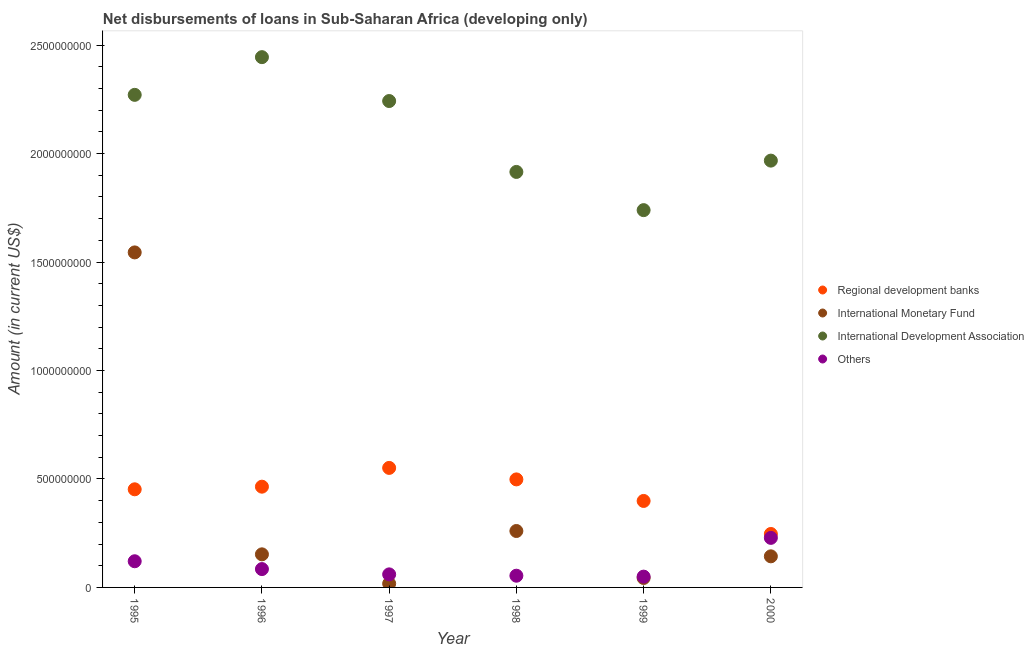How many different coloured dotlines are there?
Offer a terse response. 4. What is the amount of loan disimbursed by international development association in 1997?
Make the answer very short. 2.24e+09. Across all years, what is the maximum amount of loan disimbursed by other organisations?
Offer a very short reply. 2.28e+08. Across all years, what is the minimum amount of loan disimbursed by international monetary fund?
Your response must be concise. 1.76e+07. In which year was the amount of loan disimbursed by other organisations maximum?
Your answer should be compact. 2000. In which year was the amount of loan disimbursed by international monetary fund minimum?
Provide a short and direct response. 1997. What is the total amount of loan disimbursed by other organisations in the graph?
Give a very brief answer. 5.98e+08. What is the difference between the amount of loan disimbursed by international monetary fund in 1997 and that in 1998?
Ensure brevity in your answer.  -2.43e+08. What is the difference between the amount of loan disimbursed by other organisations in 1998 and the amount of loan disimbursed by international monetary fund in 1996?
Provide a succinct answer. -9.85e+07. What is the average amount of loan disimbursed by international monetary fund per year?
Make the answer very short. 3.60e+08. In the year 1996, what is the difference between the amount of loan disimbursed by international monetary fund and amount of loan disimbursed by other organisations?
Offer a very short reply. 6.80e+07. In how many years, is the amount of loan disimbursed by international development association greater than 900000000 US$?
Provide a succinct answer. 6. What is the ratio of the amount of loan disimbursed by other organisations in 1996 to that in 1997?
Provide a short and direct response. 1.41. Is the amount of loan disimbursed by international development association in 1997 less than that in 1999?
Your answer should be compact. No. Is the difference between the amount of loan disimbursed by international development association in 1995 and 1997 greater than the difference between the amount of loan disimbursed by regional development banks in 1995 and 1997?
Offer a very short reply. Yes. What is the difference between the highest and the second highest amount of loan disimbursed by other organisations?
Offer a very short reply. 1.08e+08. What is the difference between the highest and the lowest amount of loan disimbursed by regional development banks?
Provide a short and direct response. 3.05e+08. In how many years, is the amount of loan disimbursed by international monetary fund greater than the average amount of loan disimbursed by international monetary fund taken over all years?
Make the answer very short. 1. Is it the case that in every year, the sum of the amount of loan disimbursed by regional development banks and amount of loan disimbursed by international monetary fund is greater than the sum of amount of loan disimbursed by international development association and amount of loan disimbursed by other organisations?
Offer a very short reply. No. Is it the case that in every year, the sum of the amount of loan disimbursed by regional development banks and amount of loan disimbursed by international monetary fund is greater than the amount of loan disimbursed by international development association?
Ensure brevity in your answer.  No. Is the amount of loan disimbursed by regional development banks strictly greater than the amount of loan disimbursed by other organisations over the years?
Your response must be concise. Yes. How many dotlines are there?
Your answer should be very brief. 4. What is the difference between two consecutive major ticks on the Y-axis?
Offer a very short reply. 5.00e+08. Are the values on the major ticks of Y-axis written in scientific E-notation?
Your answer should be compact. No. How many legend labels are there?
Your answer should be compact. 4. What is the title of the graph?
Your answer should be compact. Net disbursements of loans in Sub-Saharan Africa (developing only). Does "Austria" appear as one of the legend labels in the graph?
Offer a very short reply. No. What is the label or title of the X-axis?
Offer a terse response. Year. What is the label or title of the Y-axis?
Your response must be concise. Amount (in current US$). What is the Amount (in current US$) in Regional development banks in 1995?
Keep it short and to the point. 4.52e+08. What is the Amount (in current US$) of International Monetary Fund in 1995?
Your response must be concise. 1.54e+09. What is the Amount (in current US$) in International Development Association in 1995?
Make the answer very short. 2.27e+09. What is the Amount (in current US$) of Others in 1995?
Offer a very short reply. 1.21e+08. What is the Amount (in current US$) of Regional development banks in 1996?
Provide a short and direct response. 4.64e+08. What is the Amount (in current US$) in International Monetary Fund in 1996?
Your answer should be compact. 1.53e+08. What is the Amount (in current US$) of International Development Association in 1996?
Offer a terse response. 2.44e+09. What is the Amount (in current US$) of Others in 1996?
Keep it short and to the point. 8.46e+07. What is the Amount (in current US$) in Regional development banks in 1997?
Give a very brief answer. 5.51e+08. What is the Amount (in current US$) in International Monetary Fund in 1997?
Give a very brief answer. 1.76e+07. What is the Amount (in current US$) in International Development Association in 1997?
Offer a very short reply. 2.24e+09. What is the Amount (in current US$) in Others in 1997?
Your response must be concise. 6.02e+07. What is the Amount (in current US$) in Regional development banks in 1998?
Provide a short and direct response. 4.98e+08. What is the Amount (in current US$) of International Monetary Fund in 1998?
Your answer should be very brief. 2.60e+08. What is the Amount (in current US$) of International Development Association in 1998?
Your answer should be very brief. 1.92e+09. What is the Amount (in current US$) in Others in 1998?
Make the answer very short. 5.40e+07. What is the Amount (in current US$) of Regional development banks in 1999?
Your answer should be compact. 3.99e+08. What is the Amount (in current US$) in International Monetary Fund in 1999?
Ensure brevity in your answer.  4.36e+07. What is the Amount (in current US$) of International Development Association in 1999?
Ensure brevity in your answer.  1.74e+09. What is the Amount (in current US$) of Others in 1999?
Your answer should be compact. 4.98e+07. What is the Amount (in current US$) in Regional development banks in 2000?
Your answer should be very brief. 2.46e+08. What is the Amount (in current US$) in International Monetary Fund in 2000?
Make the answer very short. 1.43e+08. What is the Amount (in current US$) in International Development Association in 2000?
Ensure brevity in your answer.  1.97e+09. What is the Amount (in current US$) in Others in 2000?
Give a very brief answer. 2.28e+08. Across all years, what is the maximum Amount (in current US$) in Regional development banks?
Make the answer very short. 5.51e+08. Across all years, what is the maximum Amount (in current US$) of International Monetary Fund?
Your answer should be compact. 1.54e+09. Across all years, what is the maximum Amount (in current US$) of International Development Association?
Your answer should be compact. 2.44e+09. Across all years, what is the maximum Amount (in current US$) of Others?
Keep it short and to the point. 2.28e+08. Across all years, what is the minimum Amount (in current US$) in Regional development banks?
Offer a terse response. 2.46e+08. Across all years, what is the minimum Amount (in current US$) of International Monetary Fund?
Make the answer very short. 1.76e+07. Across all years, what is the minimum Amount (in current US$) of International Development Association?
Ensure brevity in your answer.  1.74e+09. Across all years, what is the minimum Amount (in current US$) in Others?
Your response must be concise. 4.98e+07. What is the total Amount (in current US$) in Regional development banks in the graph?
Your response must be concise. 2.61e+09. What is the total Amount (in current US$) of International Monetary Fund in the graph?
Offer a very short reply. 2.16e+09. What is the total Amount (in current US$) of International Development Association in the graph?
Your answer should be very brief. 1.26e+1. What is the total Amount (in current US$) in Others in the graph?
Offer a terse response. 5.98e+08. What is the difference between the Amount (in current US$) of Regional development banks in 1995 and that in 1996?
Your answer should be compact. -1.21e+07. What is the difference between the Amount (in current US$) of International Monetary Fund in 1995 and that in 1996?
Give a very brief answer. 1.39e+09. What is the difference between the Amount (in current US$) of International Development Association in 1995 and that in 1996?
Offer a terse response. -1.74e+08. What is the difference between the Amount (in current US$) in Others in 1995 and that in 1996?
Your answer should be compact. 3.61e+07. What is the difference between the Amount (in current US$) of Regional development banks in 1995 and that in 1997?
Your answer should be very brief. -9.86e+07. What is the difference between the Amount (in current US$) in International Monetary Fund in 1995 and that in 1997?
Ensure brevity in your answer.  1.53e+09. What is the difference between the Amount (in current US$) in International Development Association in 1995 and that in 1997?
Make the answer very short. 2.85e+07. What is the difference between the Amount (in current US$) in Others in 1995 and that in 1997?
Make the answer very short. 6.05e+07. What is the difference between the Amount (in current US$) of Regional development banks in 1995 and that in 1998?
Offer a terse response. -4.57e+07. What is the difference between the Amount (in current US$) of International Monetary Fund in 1995 and that in 1998?
Provide a short and direct response. 1.28e+09. What is the difference between the Amount (in current US$) in International Development Association in 1995 and that in 1998?
Your response must be concise. 3.55e+08. What is the difference between the Amount (in current US$) in Others in 1995 and that in 1998?
Provide a succinct answer. 6.67e+07. What is the difference between the Amount (in current US$) in Regional development banks in 1995 and that in 1999?
Make the answer very short. 5.37e+07. What is the difference between the Amount (in current US$) of International Monetary Fund in 1995 and that in 1999?
Make the answer very short. 1.50e+09. What is the difference between the Amount (in current US$) in International Development Association in 1995 and that in 1999?
Provide a succinct answer. 5.31e+08. What is the difference between the Amount (in current US$) of Others in 1995 and that in 1999?
Keep it short and to the point. 7.09e+07. What is the difference between the Amount (in current US$) in Regional development banks in 1995 and that in 2000?
Your response must be concise. 2.06e+08. What is the difference between the Amount (in current US$) of International Monetary Fund in 1995 and that in 2000?
Your response must be concise. 1.40e+09. What is the difference between the Amount (in current US$) of International Development Association in 1995 and that in 2000?
Your response must be concise. 3.03e+08. What is the difference between the Amount (in current US$) in Others in 1995 and that in 2000?
Your answer should be compact. -1.08e+08. What is the difference between the Amount (in current US$) of Regional development banks in 1996 and that in 1997?
Offer a terse response. -8.65e+07. What is the difference between the Amount (in current US$) in International Monetary Fund in 1996 and that in 1997?
Give a very brief answer. 1.35e+08. What is the difference between the Amount (in current US$) in International Development Association in 1996 and that in 1997?
Provide a succinct answer. 2.02e+08. What is the difference between the Amount (in current US$) of Others in 1996 and that in 1997?
Offer a very short reply. 2.44e+07. What is the difference between the Amount (in current US$) in Regional development banks in 1996 and that in 1998?
Ensure brevity in your answer.  -3.36e+07. What is the difference between the Amount (in current US$) of International Monetary Fund in 1996 and that in 1998?
Provide a succinct answer. -1.08e+08. What is the difference between the Amount (in current US$) in International Development Association in 1996 and that in 1998?
Your response must be concise. 5.29e+08. What is the difference between the Amount (in current US$) in Others in 1996 and that in 1998?
Offer a terse response. 3.06e+07. What is the difference between the Amount (in current US$) in Regional development banks in 1996 and that in 1999?
Give a very brief answer. 6.58e+07. What is the difference between the Amount (in current US$) of International Monetary Fund in 1996 and that in 1999?
Give a very brief answer. 1.09e+08. What is the difference between the Amount (in current US$) in International Development Association in 1996 and that in 1999?
Your response must be concise. 7.05e+08. What is the difference between the Amount (in current US$) of Others in 1996 and that in 1999?
Provide a short and direct response. 3.48e+07. What is the difference between the Amount (in current US$) in Regional development banks in 1996 and that in 2000?
Offer a terse response. 2.18e+08. What is the difference between the Amount (in current US$) in International Monetary Fund in 1996 and that in 2000?
Ensure brevity in your answer.  9.20e+06. What is the difference between the Amount (in current US$) of International Development Association in 1996 and that in 2000?
Offer a very short reply. 4.77e+08. What is the difference between the Amount (in current US$) in Others in 1996 and that in 2000?
Offer a very short reply. -1.44e+08. What is the difference between the Amount (in current US$) in Regional development banks in 1997 and that in 1998?
Provide a succinct answer. 5.30e+07. What is the difference between the Amount (in current US$) of International Monetary Fund in 1997 and that in 1998?
Make the answer very short. -2.43e+08. What is the difference between the Amount (in current US$) of International Development Association in 1997 and that in 1998?
Give a very brief answer. 3.27e+08. What is the difference between the Amount (in current US$) of Others in 1997 and that in 1998?
Your response must be concise. 6.17e+06. What is the difference between the Amount (in current US$) of Regional development banks in 1997 and that in 1999?
Your answer should be very brief. 1.52e+08. What is the difference between the Amount (in current US$) in International Monetary Fund in 1997 and that in 1999?
Ensure brevity in your answer.  -2.60e+07. What is the difference between the Amount (in current US$) of International Development Association in 1997 and that in 1999?
Your answer should be compact. 5.03e+08. What is the difference between the Amount (in current US$) of Others in 1997 and that in 1999?
Keep it short and to the point. 1.04e+07. What is the difference between the Amount (in current US$) in Regional development banks in 1997 and that in 2000?
Make the answer very short. 3.05e+08. What is the difference between the Amount (in current US$) in International Monetary Fund in 1997 and that in 2000?
Provide a short and direct response. -1.26e+08. What is the difference between the Amount (in current US$) in International Development Association in 1997 and that in 2000?
Your response must be concise. 2.75e+08. What is the difference between the Amount (in current US$) of Others in 1997 and that in 2000?
Your answer should be very brief. -1.68e+08. What is the difference between the Amount (in current US$) in Regional development banks in 1998 and that in 1999?
Your answer should be compact. 9.93e+07. What is the difference between the Amount (in current US$) in International Monetary Fund in 1998 and that in 1999?
Provide a succinct answer. 2.17e+08. What is the difference between the Amount (in current US$) in International Development Association in 1998 and that in 1999?
Your answer should be very brief. 1.76e+08. What is the difference between the Amount (in current US$) of Others in 1998 and that in 1999?
Ensure brevity in your answer.  4.21e+06. What is the difference between the Amount (in current US$) of Regional development banks in 1998 and that in 2000?
Keep it short and to the point. 2.52e+08. What is the difference between the Amount (in current US$) of International Monetary Fund in 1998 and that in 2000?
Your answer should be compact. 1.17e+08. What is the difference between the Amount (in current US$) of International Development Association in 1998 and that in 2000?
Your answer should be compact. -5.22e+07. What is the difference between the Amount (in current US$) of Others in 1998 and that in 2000?
Make the answer very short. -1.74e+08. What is the difference between the Amount (in current US$) in Regional development banks in 1999 and that in 2000?
Keep it short and to the point. 1.52e+08. What is the difference between the Amount (in current US$) of International Monetary Fund in 1999 and that in 2000?
Provide a succinct answer. -9.98e+07. What is the difference between the Amount (in current US$) of International Development Association in 1999 and that in 2000?
Provide a succinct answer. -2.28e+08. What is the difference between the Amount (in current US$) in Others in 1999 and that in 2000?
Your response must be concise. -1.79e+08. What is the difference between the Amount (in current US$) in Regional development banks in 1995 and the Amount (in current US$) in International Monetary Fund in 1996?
Your answer should be very brief. 3.00e+08. What is the difference between the Amount (in current US$) in Regional development banks in 1995 and the Amount (in current US$) in International Development Association in 1996?
Your response must be concise. -1.99e+09. What is the difference between the Amount (in current US$) in Regional development banks in 1995 and the Amount (in current US$) in Others in 1996?
Your answer should be compact. 3.68e+08. What is the difference between the Amount (in current US$) in International Monetary Fund in 1995 and the Amount (in current US$) in International Development Association in 1996?
Make the answer very short. -9.00e+08. What is the difference between the Amount (in current US$) in International Monetary Fund in 1995 and the Amount (in current US$) in Others in 1996?
Your response must be concise. 1.46e+09. What is the difference between the Amount (in current US$) of International Development Association in 1995 and the Amount (in current US$) of Others in 1996?
Give a very brief answer. 2.19e+09. What is the difference between the Amount (in current US$) of Regional development banks in 1995 and the Amount (in current US$) of International Monetary Fund in 1997?
Offer a very short reply. 4.35e+08. What is the difference between the Amount (in current US$) of Regional development banks in 1995 and the Amount (in current US$) of International Development Association in 1997?
Make the answer very short. -1.79e+09. What is the difference between the Amount (in current US$) of Regional development banks in 1995 and the Amount (in current US$) of Others in 1997?
Offer a terse response. 3.92e+08. What is the difference between the Amount (in current US$) of International Monetary Fund in 1995 and the Amount (in current US$) of International Development Association in 1997?
Keep it short and to the point. -6.98e+08. What is the difference between the Amount (in current US$) in International Monetary Fund in 1995 and the Amount (in current US$) in Others in 1997?
Provide a succinct answer. 1.48e+09. What is the difference between the Amount (in current US$) of International Development Association in 1995 and the Amount (in current US$) of Others in 1997?
Offer a very short reply. 2.21e+09. What is the difference between the Amount (in current US$) of Regional development banks in 1995 and the Amount (in current US$) of International Monetary Fund in 1998?
Provide a succinct answer. 1.92e+08. What is the difference between the Amount (in current US$) in Regional development banks in 1995 and the Amount (in current US$) in International Development Association in 1998?
Keep it short and to the point. -1.46e+09. What is the difference between the Amount (in current US$) of Regional development banks in 1995 and the Amount (in current US$) of Others in 1998?
Make the answer very short. 3.98e+08. What is the difference between the Amount (in current US$) in International Monetary Fund in 1995 and the Amount (in current US$) in International Development Association in 1998?
Offer a very short reply. -3.71e+08. What is the difference between the Amount (in current US$) of International Monetary Fund in 1995 and the Amount (in current US$) of Others in 1998?
Offer a very short reply. 1.49e+09. What is the difference between the Amount (in current US$) in International Development Association in 1995 and the Amount (in current US$) in Others in 1998?
Your response must be concise. 2.22e+09. What is the difference between the Amount (in current US$) in Regional development banks in 1995 and the Amount (in current US$) in International Monetary Fund in 1999?
Offer a very short reply. 4.09e+08. What is the difference between the Amount (in current US$) in Regional development banks in 1995 and the Amount (in current US$) in International Development Association in 1999?
Your answer should be compact. -1.29e+09. What is the difference between the Amount (in current US$) in Regional development banks in 1995 and the Amount (in current US$) in Others in 1999?
Keep it short and to the point. 4.03e+08. What is the difference between the Amount (in current US$) of International Monetary Fund in 1995 and the Amount (in current US$) of International Development Association in 1999?
Make the answer very short. -1.95e+08. What is the difference between the Amount (in current US$) in International Monetary Fund in 1995 and the Amount (in current US$) in Others in 1999?
Keep it short and to the point. 1.49e+09. What is the difference between the Amount (in current US$) of International Development Association in 1995 and the Amount (in current US$) of Others in 1999?
Ensure brevity in your answer.  2.22e+09. What is the difference between the Amount (in current US$) in Regional development banks in 1995 and the Amount (in current US$) in International Monetary Fund in 2000?
Keep it short and to the point. 3.09e+08. What is the difference between the Amount (in current US$) in Regional development banks in 1995 and the Amount (in current US$) in International Development Association in 2000?
Provide a short and direct response. -1.52e+09. What is the difference between the Amount (in current US$) in Regional development banks in 1995 and the Amount (in current US$) in Others in 2000?
Give a very brief answer. 2.24e+08. What is the difference between the Amount (in current US$) in International Monetary Fund in 1995 and the Amount (in current US$) in International Development Association in 2000?
Your response must be concise. -4.23e+08. What is the difference between the Amount (in current US$) in International Monetary Fund in 1995 and the Amount (in current US$) in Others in 2000?
Your answer should be very brief. 1.32e+09. What is the difference between the Amount (in current US$) of International Development Association in 1995 and the Amount (in current US$) of Others in 2000?
Your response must be concise. 2.04e+09. What is the difference between the Amount (in current US$) of Regional development banks in 1996 and the Amount (in current US$) of International Monetary Fund in 1997?
Offer a very short reply. 4.47e+08. What is the difference between the Amount (in current US$) in Regional development banks in 1996 and the Amount (in current US$) in International Development Association in 1997?
Your response must be concise. -1.78e+09. What is the difference between the Amount (in current US$) in Regional development banks in 1996 and the Amount (in current US$) in Others in 1997?
Make the answer very short. 4.04e+08. What is the difference between the Amount (in current US$) of International Monetary Fund in 1996 and the Amount (in current US$) of International Development Association in 1997?
Your answer should be very brief. -2.09e+09. What is the difference between the Amount (in current US$) in International Monetary Fund in 1996 and the Amount (in current US$) in Others in 1997?
Your response must be concise. 9.24e+07. What is the difference between the Amount (in current US$) of International Development Association in 1996 and the Amount (in current US$) of Others in 1997?
Ensure brevity in your answer.  2.38e+09. What is the difference between the Amount (in current US$) of Regional development banks in 1996 and the Amount (in current US$) of International Monetary Fund in 1998?
Keep it short and to the point. 2.04e+08. What is the difference between the Amount (in current US$) of Regional development banks in 1996 and the Amount (in current US$) of International Development Association in 1998?
Your response must be concise. -1.45e+09. What is the difference between the Amount (in current US$) of Regional development banks in 1996 and the Amount (in current US$) of Others in 1998?
Provide a succinct answer. 4.10e+08. What is the difference between the Amount (in current US$) in International Monetary Fund in 1996 and the Amount (in current US$) in International Development Association in 1998?
Offer a very short reply. -1.76e+09. What is the difference between the Amount (in current US$) of International Monetary Fund in 1996 and the Amount (in current US$) of Others in 1998?
Offer a terse response. 9.85e+07. What is the difference between the Amount (in current US$) of International Development Association in 1996 and the Amount (in current US$) of Others in 1998?
Make the answer very short. 2.39e+09. What is the difference between the Amount (in current US$) in Regional development banks in 1996 and the Amount (in current US$) in International Monetary Fund in 1999?
Provide a succinct answer. 4.21e+08. What is the difference between the Amount (in current US$) in Regional development banks in 1996 and the Amount (in current US$) in International Development Association in 1999?
Your answer should be very brief. -1.27e+09. What is the difference between the Amount (in current US$) in Regional development banks in 1996 and the Amount (in current US$) in Others in 1999?
Provide a succinct answer. 4.15e+08. What is the difference between the Amount (in current US$) in International Monetary Fund in 1996 and the Amount (in current US$) in International Development Association in 1999?
Provide a short and direct response. -1.59e+09. What is the difference between the Amount (in current US$) of International Monetary Fund in 1996 and the Amount (in current US$) of Others in 1999?
Provide a succinct answer. 1.03e+08. What is the difference between the Amount (in current US$) in International Development Association in 1996 and the Amount (in current US$) in Others in 1999?
Give a very brief answer. 2.39e+09. What is the difference between the Amount (in current US$) of Regional development banks in 1996 and the Amount (in current US$) of International Monetary Fund in 2000?
Ensure brevity in your answer.  3.21e+08. What is the difference between the Amount (in current US$) in Regional development banks in 1996 and the Amount (in current US$) in International Development Association in 2000?
Keep it short and to the point. -1.50e+09. What is the difference between the Amount (in current US$) of Regional development banks in 1996 and the Amount (in current US$) of Others in 2000?
Make the answer very short. 2.36e+08. What is the difference between the Amount (in current US$) of International Monetary Fund in 1996 and the Amount (in current US$) of International Development Association in 2000?
Provide a short and direct response. -1.82e+09. What is the difference between the Amount (in current US$) of International Monetary Fund in 1996 and the Amount (in current US$) of Others in 2000?
Your answer should be very brief. -7.59e+07. What is the difference between the Amount (in current US$) of International Development Association in 1996 and the Amount (in current US$) of Others in 2000?
Your answer should be very brief. 2.22e+09. What is the difference between the Amount (in current US$) of Regional development banks in 1997 and the Amount (in current US$) of International Monetary Fund in 1998?
Keep it short and to the point. 2.91e+08. What is the difference between the Amount (in current US$) in Regional development banks in 1997 and the Amount (in current US$) in International Development Association in 1998?
Provide a succinct answer. -1.36e+09. What is the difference between the Amount (in current US$) of Regional development banks in 1997 and the Amount (in current US$) of Others in 1998?
Your answer should be very brief. 4.97e+08. What is the difference between the Amount (in current US$) in International Monetary Fund in 1997 and the Amount (in current US$) in International Development Association in 1998?
Your answer should be very brief. -1.90e+09. What is the difference between the Amount (in current US$) of International Monetary Fund in 1997 and the Amount (in current US$) of Others in 1998?
Offer a terse response. -3.64e+07. What is the difference between the Amount (in current US$) of International Development Association in 1997 and the Amount (in current US$) of Others in 1998?
Keep it short and to the point. 2.19e+09. What is the difference between the Amount (in current US$) in Regional development banks in 1997 and the Amount (in current US$) in International Monetary Fund in 1999?
Give a very brief answer. 5.07e+08. What is the difference between the Amount (in current US$) of Regional development banks in 1997 and the Amount (in current US$) of International Development Association in 1999?
Give a very brief answer. -1.19e+09. What is the difference between the Amount (in current US$) of Regional development banks in 1997 and the Amount (in current US$) of Others in 1999?
Provide a succinct answer. 5.01e+08. What is the difference between the Amount (in current US$) of International Monetary Fund in 1997 and the Amount (in current US$) of International Development Association in 1999?
Your answer should be very brief. -1.72e+09. What is the difference between the Amount (in current US$) of International Monetary Fund in 1997 and the Amount (in current US$) of Others in 1999?
Your answer should be compact. -3.22e+07. What is the difference between the Amount (in current US$) of International Development Association in 1997 and the Amount (in current US$) of Others in 1999?
Your answer should be compact. 2.19e+09. What is the difference between the Amount (in current US$) of Regional development banks in 1997 and the Amount (in current US$) of International Monetary Fund in 2000?
Offer a very short reply. 4.08e+08. What is the difference between the Amount (in current US$) of Regional development banks in 1997 and the Amount (in current US$) of International Development Association in 2000?
Your response must be concise. -1.42e+09. What is the difference between the Amount (in current US$) of Regional development banks in 1997 and the Amount (in current US$) of Others in 2000?
Offer a terse response. 3.23e+08. What is the difference between the Amount (in current US$) of International Monetary Fund in 1997 and the Amount (in current US$) of International Development Association in 2000?
Provide a short and direct response. -1.95e+09. What is the difference between the Amount (in current US$) in International Monetary Fund in 1997 and the Amount (in current US$) in Others in 2000?
Give a very brief answer. -2.11e+08. What is the difference between the Amount (in current US$) in International Development Association in 1997 and the Amount (in current US$) in Others in 2000?
Provide a succinct answer. 2.01e+09. What is the difference between the Amount (in current US$) of Regional development banks in 1998 and the Amount (in current US$) of International Monetary Fund in 1999?
Keep it short and to the point. 4.54e+08. What is the difference between the Amount (in current US$) of Regional development banks in 1998 and the Amount (in current US$) of International Development Association in 1999?
Your answer should be very brief. -1.24e+09. What is the difference between the Amount (in current US$) of Regional development banks in 1998 and the Amount (in current US$) of Others in 1999?
Your answer should be very brief. 4.48e+08. What is the difference between the Amount (in current US$) in International Monetary Fund in 1998 and the Amount (in current US$) in International Development Association in 1999?
Provide a succinct answer. -1.48e+09. What is the difference between the Amount (in current US$) in International Monetary Fund in 1998 and the Amount (in current US$) in Others in 1999?
Ensure brevity in your answer.  2.10e+08. What is the difference between the Amount (in current US$) of International Development Association in 1998 and the Amount (in current US$) of Others in 1999?
Ensure brevity in your answer.  1.87e+09. What is the difference between the Amount (in current US$) in Regional development banks in 1998 and the Amount (in current US$) in International Monetary Fund in 2000?
Your answer should be very brief. 3.55e+08. What is the difference between the Amount (in current US$) of Regional development banks in 1998 and the Amount (in current US$) of International Development Association in 2000?
Your answer should be compact. -1.47e+09. What is the difference between the Amount (in current US$) in Regional development banks in 1998 and the Amount (in current US$) in Others in 2000?
Your answer should be very brief. 2.70e+08. What is the difference between the Amount (in current US$) in International Monetary Fund in 1998 and the Amount (in current US$) in International Development Association in 2000?
Provide a short and direct response. -1.71e+09. What is the difference between the Amount (in current US$) of International Monetary Fund in 1998 and the Amount (in current US$) of Others in 2000?
Offer a very short reply. 3.17e+07. What is the difference between the Amount (in current US$) in International Development Association in 1998 and the Amount (in current US$) in Others in 2000?
Make the answer very short. 1.69e+09. What is the difference between the Amount (in current US$) of Regional development banks in 1999 and the Amount (in current US$) of International Monetary Fund in 2000?
Keep it short and to the point. 2.55e+08. What is the difference between the Amount (in current US$) of Regional development banks in 1999 and the Amount (in current US$) of International Development Association in 2000?
Ensure brevity in your answer.  -1.57e+09. What is the difference between the Amount (in current US$) in Regional development banks in 1999 and the Amount (in current US$) in Others in 2000?
Offer a very short reply. 1.70e+08. What is the difference between the Amount (in current US$) of International Monetary Fund in 1999 and the Amount (in current US$) of International Development Association in 2000?
Your answer should be compact. -1.92e+09. What is the difference between the Amount (in current US$) in International Monetary Fund in 1999 and the Amount (in current US$) in Others in 2000?
Your answer should be very brief. -1.85e+08. What is the difference between the Amount (in current US$) in International Development Association in 1999 and the Amount (in current US$) in Others in 2000?
Your answer should be compact. 1.51e+09. What is the average Amount (in current US$) of Regional development banks per year?
Keep it short and to the point. 4.35e+08. What is the average Amount (in current US$) in International Monetary Fund per year?
Your answer should be very brief. 3.60e+08. What is the average Amount (in current US$) of International Development Association per year?
Make the answer very short. 2.10e+09. What is the average Amount (in current US$) in Others per year?
Provide a short and direct response. 9.96e+07. In the year 1995, what is the difference between the Amount (in current US$) in Regional development banks and Amount (in current US$) in International Monetary Fund?
Offer a terse response. -1.09e+09. In the year 1995, what is the difference between the Amount (in current US$) of Regional development banks and Amount (in current US$) of International Development Association?
Give a very brief answer. -1.82e+09. In the year 1995, what is the difference between the Amount (in current US$) in Regional development banks and Amount (in current US$) in Others?
Provide a short and direct response. 3.32e+08. In the year 1995, what is the difference between the Amount (in current US$) of International Monetary Fund and Amount (in current US$) of International Development Association?
Offer a terse response. -7.26e+08. In the year 1995, what is the difference between the Amount (in current US$) in International Monetary Fund and Amount (in current US$) in Others?
Your response must be concise. 1.42e+09. In the year 1995, what is the difference between the Amount (in current US$) of International Development Association and Amount (in current US$) of Others?
Your response must be concise. 2.15e+09. In the year 1996, what is the difference between the Amount (in current US$) of Regional development banks and Amount (in current US$) of International Monetary Fund?
Provide a short and direct response. 3.12e+08. In the year 1996, what is the difference between the Amount (in current US$) of Regional development banks and Amount (in current US$) of International Development Association?
Your answer should be compact. -1.98e+09. In the year 1996, what is the difference between the Amount (in current US$) of Regional development banks and Amount (in current US$) of Others?
Provide a short and direct response. 3.80e+08. In the year 1996, what is the difference between the Amount (in current US$) of International Monetary Fund and Amount (in current US$) of International Development Association?
Provide a succinct answer. -2.29e+09. In the year 1996, what is the difference between the Amount (in current US$) in International Monetary Fund and Amount (in current US$) in Others?
Provide a succinct answer. 6.80e+07. In the year 1996, what is the difference between the Amount (in current US$) of International Development Association and Amount (in current US$) of Others?
Give a very brief answer. 2.36e+09. In the year 1997, what is the difference between the Amount (in current US$) in Regional development banks and Amount (in current US$) in International Monetary Fund?
Provide a short and direct response. 5.33e+08. In the year 1997, what is the difference between the Amount (in current US$) in Regional development banks and Amount (in current US$) in International Development Association?
Provide a succinct answer. -1.69e+09. In the year 1997, what is the difference between the Amount (in current US$) in Regional development banks and Amount (in current US$) in Others?
Offer a very short reply. 4.91e+08. In the year 1997, what is the difference between the Amount (in current US$) in International Monetary Fund and Amount (in current US$) in International Development Association?
Keep it short and to the point. -2.22e+09. In the year 1997, what is the difference between the Amount (in current US$) of International Monetary Fund and Amount (in current US$) of Others?
Ensure brevity in your answer.  -4.26e+07. In the year 1997, what is the difference between the Amount (in current US$) of International Development Association and Amount (in current US$) of Others?
Offer a terse response. 2.18e+09. In the year 1998, what is the difference between the Amount (in current US$) in Regional development banks and Amount (in current US$) in International Monetary Fund?
Make the answer very short. 2.38e+08. In the year 1998, what is the difference between the Amount (in current US$) in Regional development banks and Amount (in current US$) in International Development Association?
Offer a very short reply. -1.42e+09. In the year 1998, what is the difference between the Amount (in current US$) of Regional development banks and Amount (in current US$) of Others?
Provide a succinct answer. 4.44e+08. In the year 1998, what is the difference between the Amount (in current US$) in International Monetary Fund and Amount (in current US$) in International Development Association?
Ensure brevity in your answer.  -1.66e+09. In the year 1998, what is the difference between the Amount (in current US$) of International Monetary Fund and Amount (in current US$) of Others?
Ensure brevity in your answer.  2.06e+08. In the year 1998, what is the difference between the Amount (in current US$) of International Development Association and Amount (in current US$) of Others?
Your answer should be very brief. 1.86e+09. In the year 1999, what is the difference between the Amount (in current US$) in Regional development banks and Amount (in current US$) in International Monetary Fund?
Your answer should be very brief. 3.55e+08. In the year 1999, what is the difference between the Amount (in current US$) of Regional development banks and Amount (in current US$) of International Development Association?
Offer a very short reply. -1.34e+09. In the year 1999, what is the difference between the Amount (in current US$) in Regional development banks and Amount (in current US$) in Others?
Your answer should be compact. 3.49e+08. In the year 1999, what is the difference between the Amount (in current US$) in International Monetary Fund and Amount (in current US$) in International Development Association?
Keep it short and to the point. -1.70e+09. In the year 1999, what is the difference between the Amount (in current US$) of International Monetary Fund and Amount (in current US$) of Others?
Provide a short and direct response. -6.21e+06. In the year 1999, what is the difference between the Amount (in current US$) of International Development Association and Amount (in current US$) of Others?
Your answer should be very brief. 1.69e+09. In the year 2000, what is the difference between the Amount (in current US$) of Regional development banks and Amount (in current US$) of International Monetary Fund?
Your answer should be compact. 1.03e+08. In the year 2000, what is the difference between the Amount (in current US$) of Regional development banks and Amount (in current US$) of International Development Association?
Give a very brief answer. -1.72e+09. In the year 2000, what is the difference between the Amount (in current US$) of Regional development banks and Amount (in current US$) of Others?
Give a very brief answer. 1.79e+07. In the year 2000, what is the difference between the Amount (in current US$) in International Monetary Fund and Amount (in current US$) in International Development Association?
Ensure brevity in your answer.  -1.82e+09. In the year 2000, what is the difference between the Amount (in current US$) of International Monetary Fund and Amount (in current US$) of Others?
Your answer should be very brief. -8.51e+07. In the year 2000, what is the difference between the Amount (in current US$) of International Development Association and Amount (in current US$) of Others?
Make the answer very short. 1.74e+09. What is the ratio of the Amount (in current US$) in Regional development banks in 1995 to that in 1996?
Ensure brevity in your answer.  0.97. What is the ratio of the Amount (in current US$) in International Monetary Fund in 1995 to that in 1996?
Offer a terse response. 10.12. What is the ratio of the Amount (in current US$) of International Development Association in 1995 to that in 1996?
Your answer should be compact. 0.93. What is the ratio of the Amount (in current US$) in Others in 1995 to that in 1996?
Make the answer very short. 1.43. What is the ratio of the Amount (in current US$) of Regional development banks in 1995 to that in 1997?
Ensure brevity in your answer.  0.82. What is the ratio of the Amount (in current US$) in International Monetary Fund in 1995 to that in 1997?
Give a very brief answer. 87.78. What is the ratio of the Amount (in current US$) of International Development Association in 1995 to that in 1997?
Provide a succinct answer. 1.01. What is the ratio of the Amount (in current US$) of Others in 1995 to that in 1997?
Your answer should be very brief. 2.01. What is the ratio of the Amount (in current US$) in Regional development banks in 1995 to that in 1998?
Provide a succinct answer. 0.91. What is the ratio of the Amount (in current US$) of International Monetary Fund in 1995 to that in 1998?
Your answer should be compact. 5.94. What is the ratio of the Amount (in current US$) of International Development Association in 1995 to that in 1998?
Provide a short and direct response. 1.19. What is the ratio of the Amount (in current US$) of Others in 1995 to that in 1998?
Keep it short and to the point. 2.23. What is the ratio of the Amount (in current US$) in Regional development banks in 1995 to that in 1999?
Make the answer very short. 1.13. What is the ratio of the Amount (in current US$) of International Monetary Fund in 1995 to that in 1999?
Ensure brevity in your answer.  35.44. What is the ratio of the Amount (in current US$) in International Development Association in 1995 to that in 1999?
Keep it short and to the point. 1.31. What is the ratio of the Amount (in current US$) of Others in 1995 to that in 1999?
Your answer should be very brief. 2.42. What is the ratio of the Amount (in current US$) of Regional development banks in 1995 to that in 2000?
Your answer should be very brief. 1.84. What is the ratio of the Amount (in current US$) in International Monetary Fund in 1995 to that in 2000?
Provide a succinct answer. 10.77. What is the ratio of the Amount (in current US$) of International Development Association in 1995 to that in 2000?
Give a very brief answer. 1.15. What is the ratio of the Amount (in current US$) in Others in 1995 to that in 2000?
Provide a succinct answer. 0.53. What is the ratio of the Amount (in current US$) of Regional development banks in 1996 to that in 1997?
Your response must be concise. 0.84. What is the ratio of the Amount (in current US$) in International Monetary Fund in 1996 to that in 1997?
Your response must be concise. 8.67. What is the ratio of the Amount (in current US$) of International Development Association in 1996 to that in 1997?
Your answer should be compact. 1.09. What is the ratio of the Amount (in current US$) of Others in 1996 to that in 1997?
Give a very brief answer. 1.41. What is the ratio of the Amount (in current US$) of Regional development banks in 1996 to that in 1998?
Your response must be concise. 0.93. What is the ratio of the Amount (in current US$) of International Monetary Fund in 1996 to that in 1998?
Make the answer very short. 0.59. What is the ratio of the Amount (in current US$) of International Development Association in 1996 to that in 1998?
Give a very brief answer. 1.28. What is the ratio of the Amount (in current US$) in Others in 1996 to that in 1998?
Offer a very short reply. 1.57. What is the ratio of the Amount (in current US$) of Regional development banks in 1996 to that in 1999?
Your response must be concise. 1.17. What is the ratio of the Amount (in current US$) of International Monetary Fund in 1996 to that in 1999?
Offer a very short reply. 3.5. What is the ratio of the Amount (in current US$) of International Development Association in 1996 to that in 1999?
Your answer should be compact. 1.41. What is the ratio of the Amount (in current US$) in Others in 1996 to that in 1999?
Give a very brief answer. 1.7. What is the ratio of the Amount (in current US$) of Regional development banks in 1996 to that in 2000?
Ensure brevity in your answer.  1.89. What is the ratio of the Amount (in current US$) of International Monetary Fund in 1996 to that in 2000?
Keep it short and to the point. 1.06. What is the ratio of the Amount (in current US$) of International Development Association in 1996 to that in 2000?
Provide a succinct answer. 1.24. What is the ratio of the Amount (in current US$) in Others in 1996 to that in 2000?
Offer a terse response. 0.37. What is the ratio of the Amount (in current US$) of Regional development banks in 1997 to that in 1998?
Keep it short and to the point. 1.11. What is the ratio of the Amount (in current US$) in International Monetary Fund in 1997 to that in 1998?
Your answer should be very brief. 0.07. What is the ratio of the Amount (in current US$) of International Development Association in 1997 to that in 1998?
Provide a succinct answer. 1.17. What is the ratio of the Amount (in current US$) of Others in 1997 to that in 1998?
Your response must be concise. 1.11. What is the ratio of the Amount (in current US$) of Regional development banks in 1997 to that in 1999?
Offer a very short reply. 1.38. What is the ratio of the Amount (in current US$) of International Monetary Fund in 1997 to that in 1999?
Make the answer very short. 0.4. What is the ratio of the Amount (in current US$) of International Development Association in 1997 to that in 1999?
Your answer should be very brief. 1.29. What is the ratio of the Amount (in current US$) in Others in 1997 to that in 1999?
Provide a succinct answer. 1.21. What is the ratio of the Amount (in current US$) in Regional development banks in 1997 to that in 2000?
Provide a short and direct response. 2.24. What is the ratio of the Amount (in current US$) in International Monetary Fund in 1997 to that in 2000?
Give a very brief answer. 0.12. What is the ratio of the Amount (in current US$) in International Development Association in 1997 to that in 2000?
Offer a terse response. 1.14. What is the ratio of the Amount (in current US$) in Others in 1997 to that in 2000?
Provide a short and direct response. 0.26. What is the ratio of the Amount (in current US$) of Regional development banks in 1998 to that in 1999?
Ensure brevity in your answer.  1.25. What is the ratio of the Amount (in current US$) of International Monetary Fund in 1998 to that in 1999?
Your answer should be compact. 5.97. What is the ratio of the Amount (in current US$) in International Development Association in 1998 to that in 1999?
Keep it short and to the point. 1.1. What is the ratio of the Amount (in current US$) of Others in 1998 to that in 1999?
Make the answer very short. 1.08. What is the ratio of the Amount (in current US$) in Regional development banks in 1998 to that in 2000?
Offer a very short reply. 2.02. What is the ratio of the Amount (in current US$) in International Monetary Fund in 1998 to that in 2000?
Give a very brief answer. 1.81. What is the ratio of the Amount (in current US$) of International Development Association in 1998 to that in 2000?
Provide a short and direct response. 0.97. What is the ratio of the Amount (in current US$) in Others in 1998 to that in 2000?
Your answer should be compact. 0.24. What is the ratio of the Amount (in current US$) in Regional development banks in 1999 to that in 2000?
Ensure brevity in your answer.  1.62. What is the ratio of the Amount (in current US$) in International Monetary Fund in 1999 to that in 2000?
Your response must be concise. 0.3. What is the ratio of the Amount (in current US$) in International Development Association in 1999 to that in 2000?
Give a very brief answer. 0.88. What is the ratio of the Amount (in current US$) in Others in 1999 to that in 2000?
Your answer should be very brief. 0.22. What is the difference between the highest and the second highest Amount (in current US$) of Regional development banks?
Your answer should be compact. 5.30e+07. What is the difference between the highest and the second highest Amount (in current US$) in International Monetary Fund?
Your answer should be compact. 1.28e+09. What is the difference between the highest and the second highest Amount (in current US$) of International Development Association?
Your response must be concise. 1.74e+08. What is the difference between the highest and the second highest Amount (in current US$) of Others?
Ensure brevity in your answer.  1.08e+08. What is the difference between the highest and the lowest Amount (in current US$) in Regional development banks?
Give a very brief answer. 3.05e+08. What is the difference between the highest and the lowest Amount (in current US$) of International Monetary Fund?
Provide a succinct answer. 1.53e+09. What is the difference between the highest and the lowest Amount (in current US$) in International Development Association?
Make the answer very short. 7.05e+08. What is the difference between the highest and the lowest Amount (in current US$) of Others?
Provide a succinct answer. 1.79e+08. 